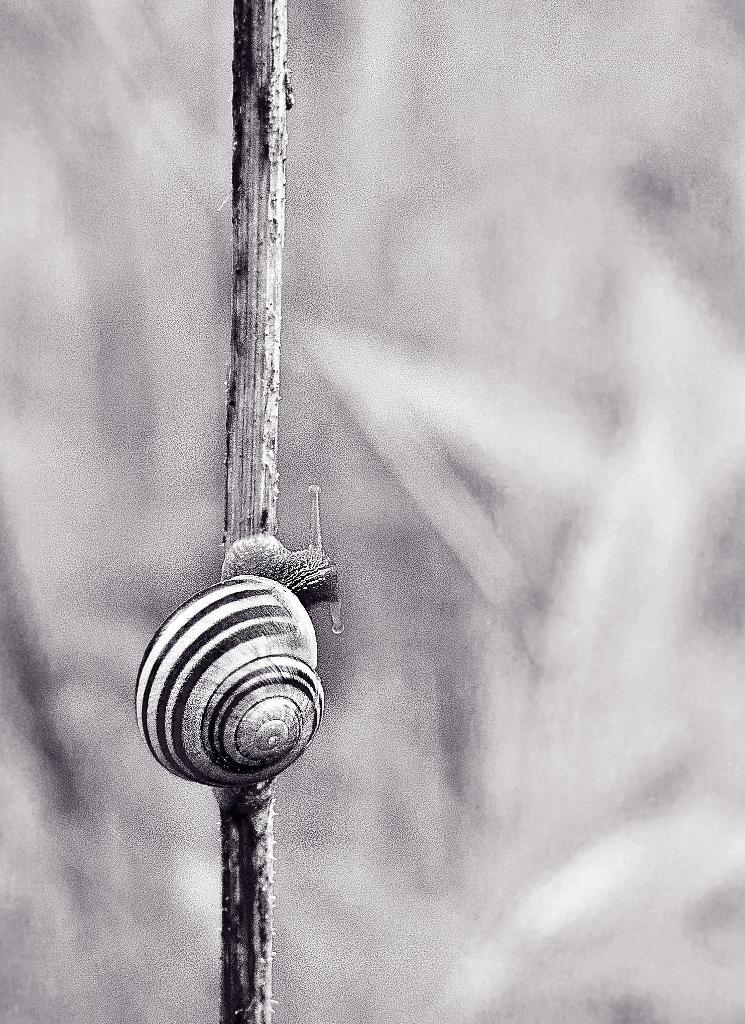What is the main subject of the image? There is a snail in the image. What is the snail resting on or attached to? The snail is on an object. Can you describe the background of the image? The background of the image is blurred. What type of stocking is the snail wearing in the image? There is no stocking present on the snail in the image. What song is the snail singing in the image? Snails do not have the ability to sing, and there is no song being sung in the image. 